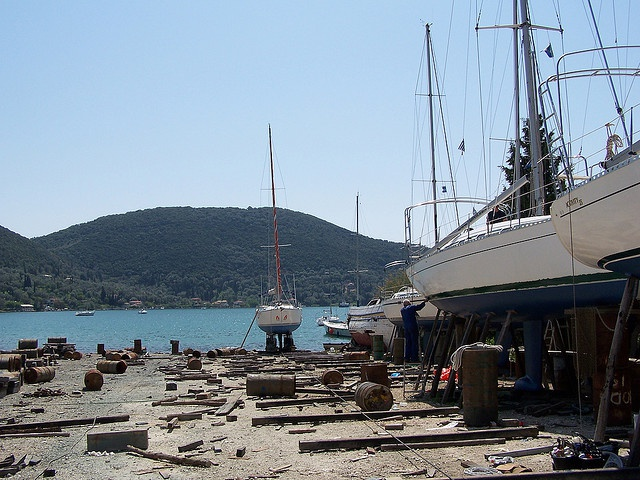Describe the objects in this image and their specific colors. I can see boat in lightblue, gray, and black tones, boat in lightblue, gray, black, and darkgray tones, boat in lightblue and gray tones, boat in lightblue, gray, darkgray, and black tones, and people in lightblue, black, gray, darkgray, and navy tones in this image. 